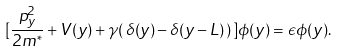Convert formula to latex. <formula><loc_0><loc_0><loc_500><loc_500>[ \frac { p _ { y } ^ { 2 } } { 2 m ^ { * } } + V ( y ) + \gamma ( \, \delta ( y ) - \delta ( y - L ) \, ) \, ] \phi ( y ) = \epsilon \phi ( y ) .</formula> 